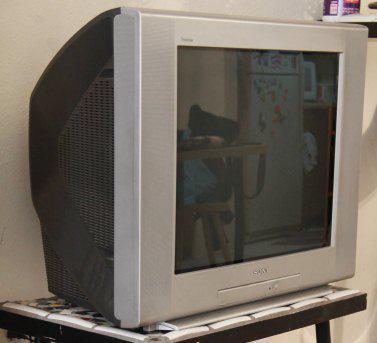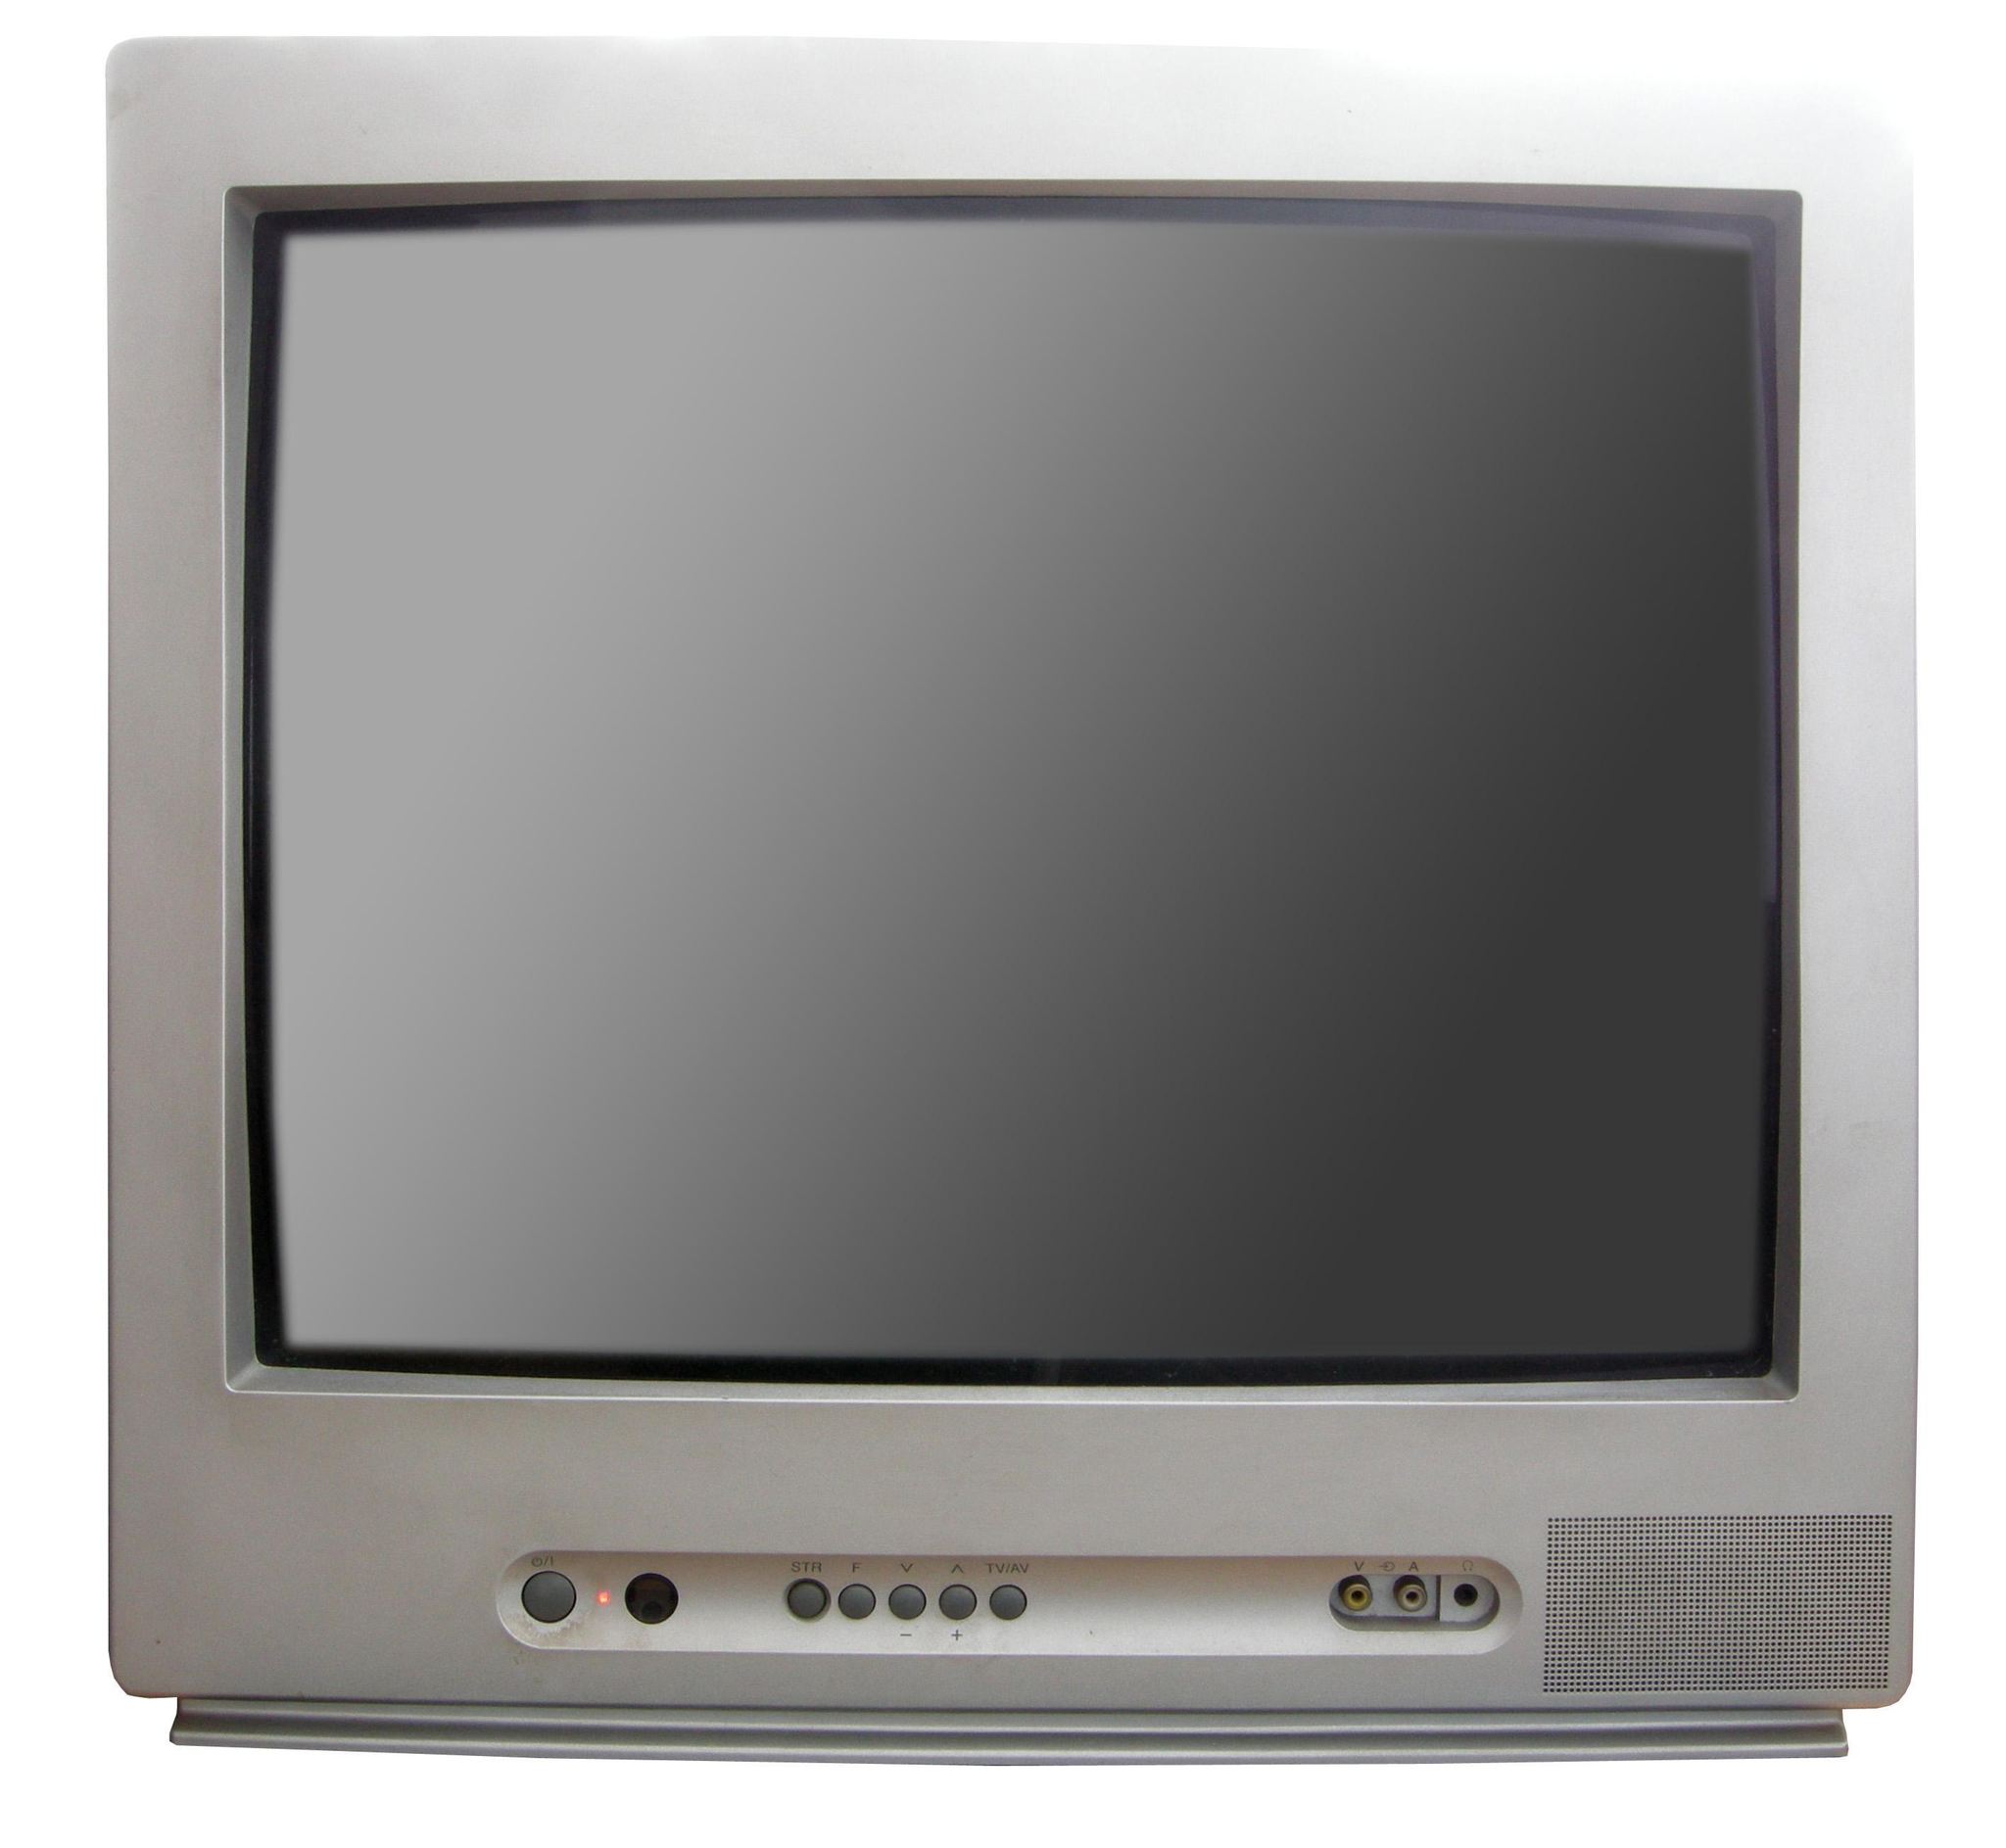The first image is the image on the left, the second image is the image on the right. For the images displayed, is the sentence "One image shows an old-fashioned TV set with two large knobs arranged vertically alongside the screen." factually correct? Answer yes or no. No. The first image is the image on the left, the second image is the image on the right. Examine the images to the left and right. Is the description "Two televisions have the same boxy shape and screens, but one has visible tuning controls at the bottom while the other has a small panel door in the same place." accurate? Answer yes or no. Yes. 